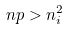Convert formula to latex. <formula><loc_0><loc_0><loc_500><loc_500>n p > n _ { i } ^ { 2 }</formula> 